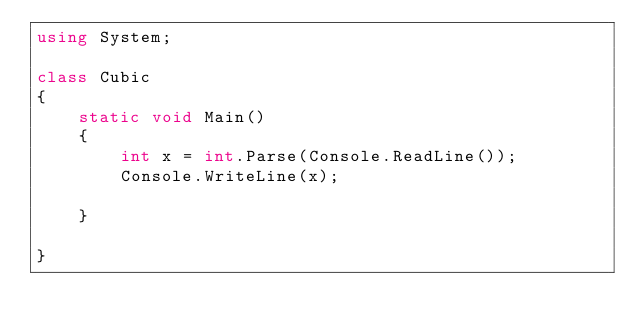Convert code to text. <code><loc_0><loc_0><loc_500><loc_500><_C#_>using System;

class Cubic
{
	static void Main()
	{
		int x = int.Parse(Console.ReadLine());
		Console.WriteLine(x);
		
	}
	
}</code> 